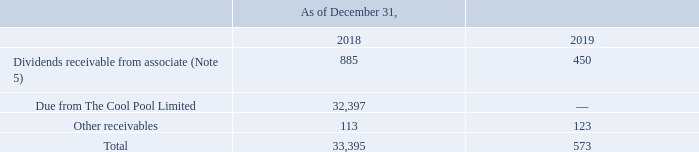GasLog Ltd. and its Subsidiaries
Notes to the consolidated financial statements (Continued)
For the years ended December 31, 2017, 2018 and 2019
(All amounts expressed in thousands of U.S. Dollars, except share and per share data)
21. Related Party Transactions
The Group had the following balances with related parties which have been included in the consolidated statements of financial position:
Current Assets
Dividends receivable and other amounts due from related parties
On June 28, 2019, GasLog transferred to Golar its 100 shares of the common capital stock of the Cool Pool Limited (Note 1). As of December 31, 2019, the receivable balance from the Cool Pool is nil.
How many shares of Cool Pool Limited was transferred to Golar? 100. What is the amount due from The Cool Pool Limited in 2018?
Answer scale should be: thousand. 32,397. In which years was the dividends receivable and other amounts due from related parties recorded for? 2018, 2019. Which year was the dividends receivable from associate higher? 885 > 450
Answer: 2018. What was the change in other receivables from 2018 to 2019?
Answer scale should be: thousand. 123 - 113 
Answer: 10. What was the percentage change in total from 2018 to 2019?
Answer scale should be: percent. (573 - 33,395)/33,395 
Answer: -98.28. 